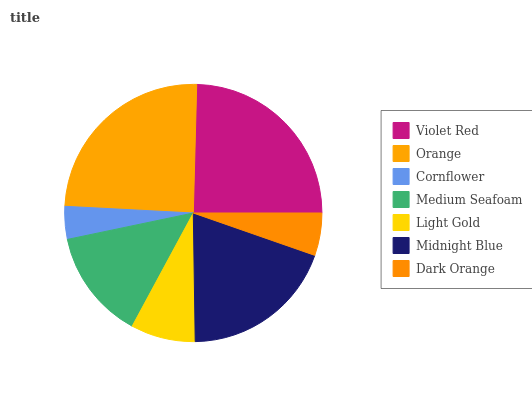Is Cornflower the minimum?
Answer yes or no. Yes. Is Orange the maximum?
Answer yes or no. Yes. Is Orange the minimum?
Answer yes or no. No. Is Cornflower the maximum?
Answer yes or no. No. Is Orange greater than Cornflower?
Answer yes or no. Yes. Is Cornflower less than Orange?
Answer yes or no. Yes. Is Cornflower greater than Orange?
Answer yes or no. No. Is Orange less than Cornflower?
Answer yes or no. No. Is Medium Seafoam the high median?
Answer yes or no. Yes. Is Medium Seafoam the low median?
Answer yes or no. Yes. Is Light Gold the high median?
Answer yes or no. No. Is Orange the low median?
Answer yes or no. No. 